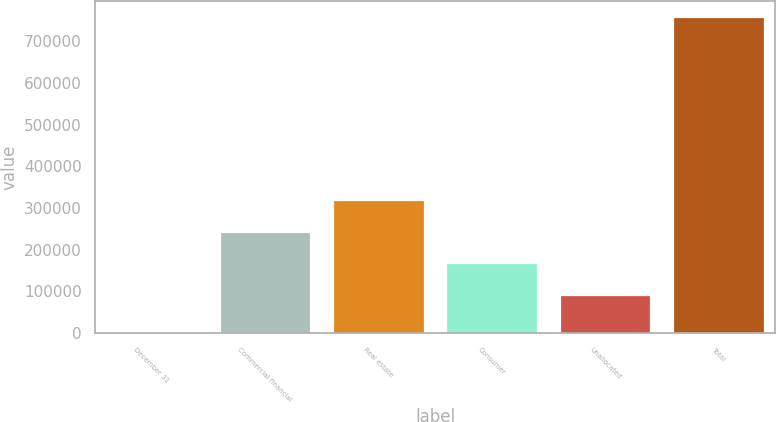Convert chart. <chart><loc_0><loc_0><loc_500><loc_500><bar_chart><fcel>December 31<fcel>Commercial financial<fcel>Real estate<fcel>Consumer<fcel>Unallocated<fcel>Total<nl><fcel>2007<fcel>243727<fcel>319470<fcel>167984<fcel>91495<fcel>759439<nl></chart> 